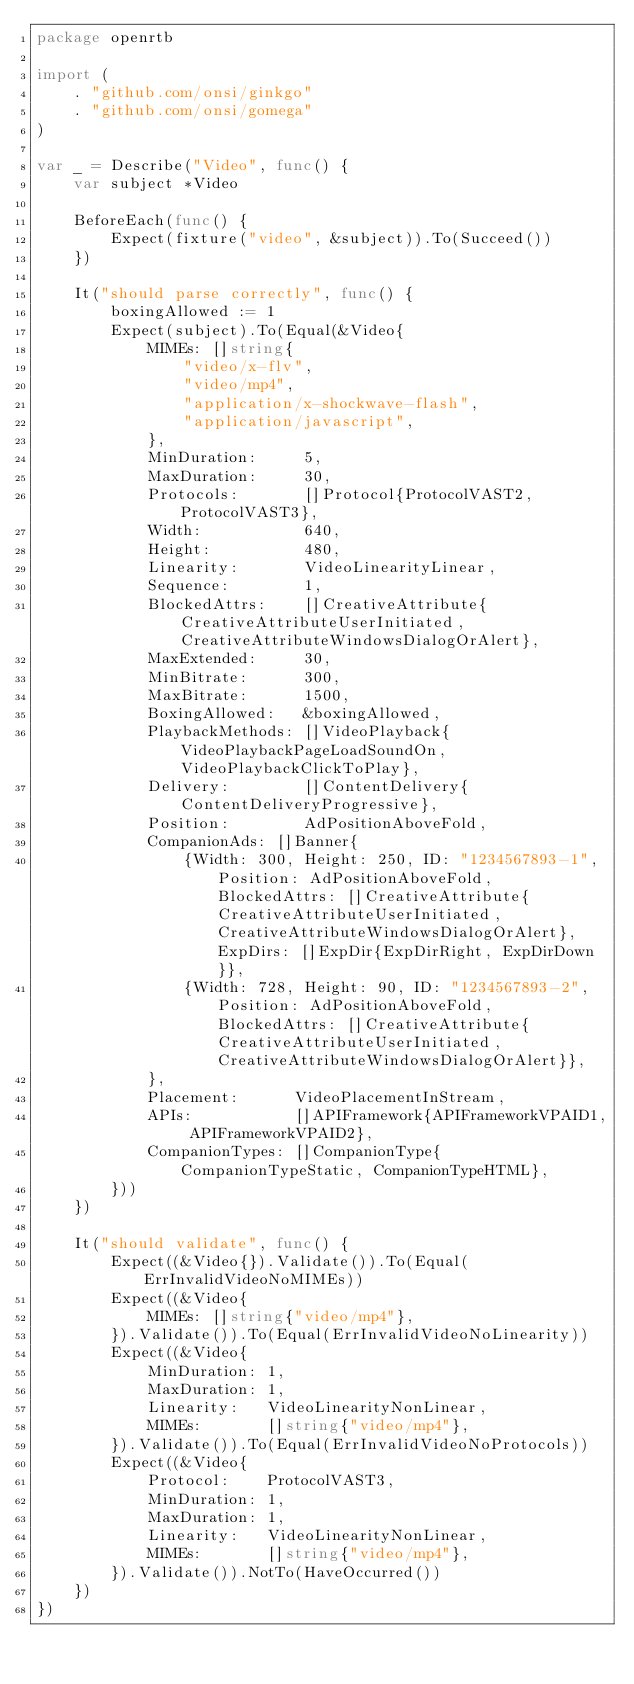Convert code to text. <code><loc_0><loc_0><loc_500><loc_500><_Go_>package openrtb

import (
	. "github.com/onsi/ginkgo"
	. "github.com/onsi/gomega"
)

var _ = Describe("Video", func() {
	var subject *Video

	BeforeEach(func() {
		Expect(fixture("video", &subject)).To(Succeed())
	})

	It("should parse correctly", func() {
		boxingAllowed := 1
		Expect(subject).To(Equal(&Video{
			MIMEs: []string{
				"video/x-flv",
				"video/mp4",
				"application/x-shockwave-flash",
				"application/javascript",
			},
			MinDuration:     5,
			MaxDuration:     30,
			Protocols:       []Protocol{ProtocolVAST2, ProtocolVAST3},
			Width:           640,
			Height:          480,
			Linearity:       VideoLinearityLinear,
			Sequence:        1,
			BlockedAttrs:    []CreativeAttribute{CreativeAttributeUserInitiated, CreativeAttributeWindowsDialogOrAlert},
			MaxExtended:     30,
			MinBitrate:      300,
			MaxBitrate:      1500,
			BoxingAllowed:   &boxingAllowed,
			PlaybackMethods: []VideoPlayback{VideoPlaybackPageLoadSoundOn, VideoPlaybackClickToPlay},
			Delivery:        []ContentDelivery{ContentDeliveryProgressive},
			Position:        AdPositionAboveFold,
			CompanionAds: []Banner{
				{Width: 300, Height: 250, ID: "1234567893-1", Position: AdPositionAboveFold, BlockedAttrs: []CreativeAttribute{CreativeAttributeUserInitiated, CreativeAttributeWindowsDialogOrAlert}, ExpDirs: []ExpDir{ExpDirRight, ExpDirDown}},
				{Width: 728, Height: 90, ID: "1234567893-2", Position: AdPositionAboveFold, BlockedAttrs: []CreativeAttribute{CreativeAttributeUserInitiated, CreativeAttributeWindowsDialogOrAlert}},
			},
			Placement:      VideoPlacementInStream,
			APIs:           []APIFramework{APIFrameworkVPAID1, APIFrameworkVPAID2},
			CompanionTypes: []CompanionType{CompanionTypeStatic, CompanionTypeHTML},
		}))
	})

	It("should validate", func() {
		Expect((&Video{}).Validate()).To(Equal(ErrInvalidVideoNoMIMEs))
		Expect((&Video{
			MIMEs: []string{"video/mp4"},
		}).Validate()).To(Equal(ErrInvalidVideoNoLinearity))
		Expect((&Video{
			MinDuration: 1,
			MaxDuration: 1,
			Linearity:   VideoLinearityNonLinear,
			MIMEs:       []string{"video/mp4"},
		}).Validate()).To(Equal(ErrInvalidVideoNoProtocols))
		Expect((&Video{
			Protocol:    ProtocolVAST3,
			MinDuration: 1,
			MaxDuration: 1,
			Linearity:   VideoLinearityNonLinear,
			MIMEs:       []string{"video/mp4"},
		}).Validate()).NotTo(HaveOccurred())
	})
})
</code> 